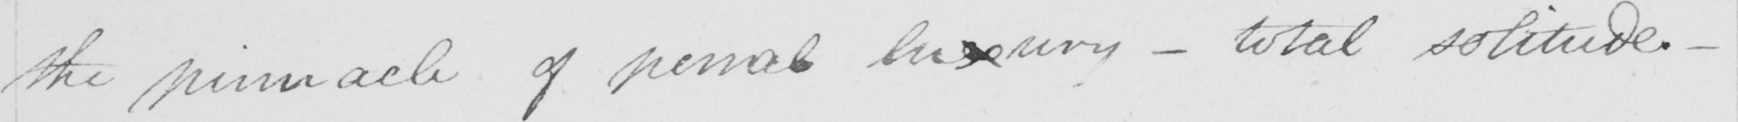Can you tell me what this handwritten text says? the pinnacle of penal luxury  _  total solitude .  _ 